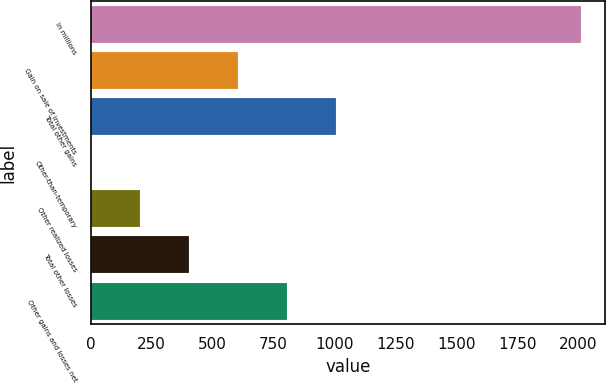Convert chart to OTSL. <chart><loc_0><loc_0><loc_500><loc_500><bar_chart><fcel>in millions<fcel>Gain on sale of investments<fcel>Total other gains<fcel>Other-than-temporary<fcel>Other realized losses<fcel>Total other losses<fcel>Other gains and losses net<nl><fcel>2011<fcel>604<fcel>1006<fcel>1<fcel>202<fcel>403<fcel>805<nl></chart> 